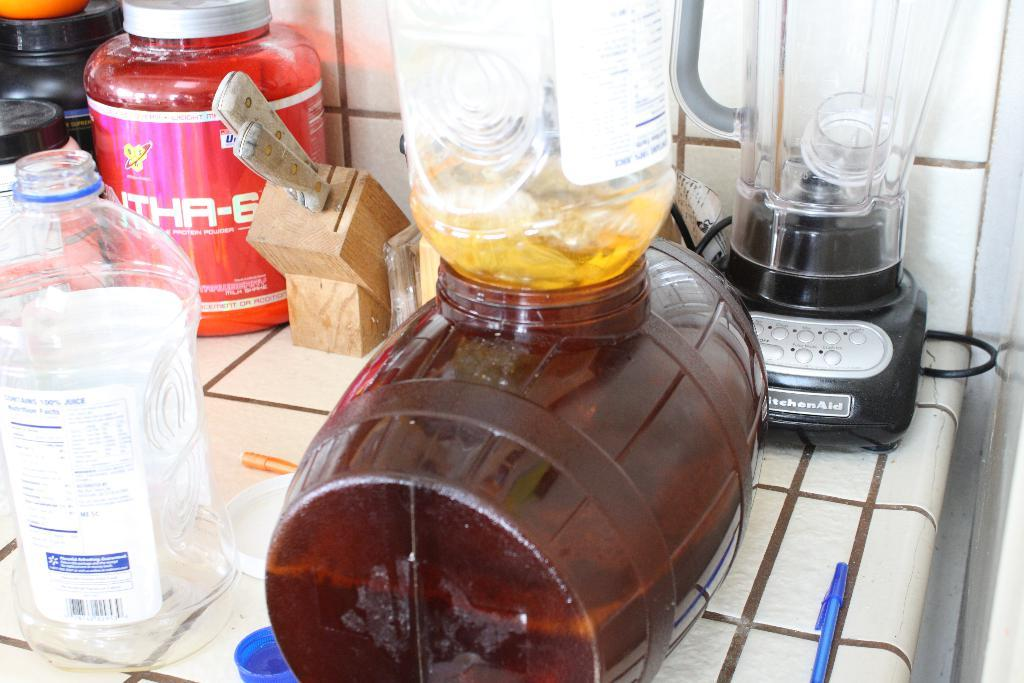<image>
Share a concise interpretation of the image provided. the word Aid is on the front of the blender 